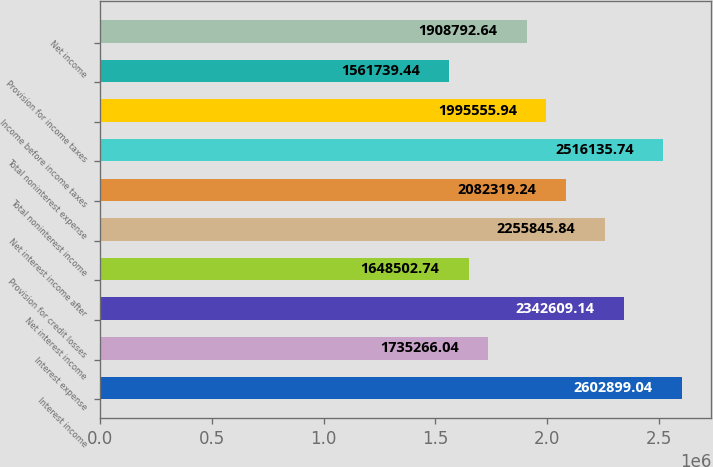<chart> <loc_0><loc_0><loc_500><loc_500><bar_chart><fcel>Interest income<fcel>Interest expense<fcel>Net interest income<fcel>Provision for credit losses<fcel>Net interest income after<fcel>Total noninterest income<fcel>Total noninterest expense<fcel>Income before income taxes<fcel>Provision for income taxes<fcel>Net income<nl><fcel>2.6029e+06<fcel>1.73527e+06<fcel>2.34261e+06<fcel>1.6485e+06<fcel>2.25585e+06<fcel>2.08232e+06<fcel>2.51614e+06<fcel>1.99556e+06<fcel>1.56174e+06<fcel>1.90879e+06<nl></chart> 